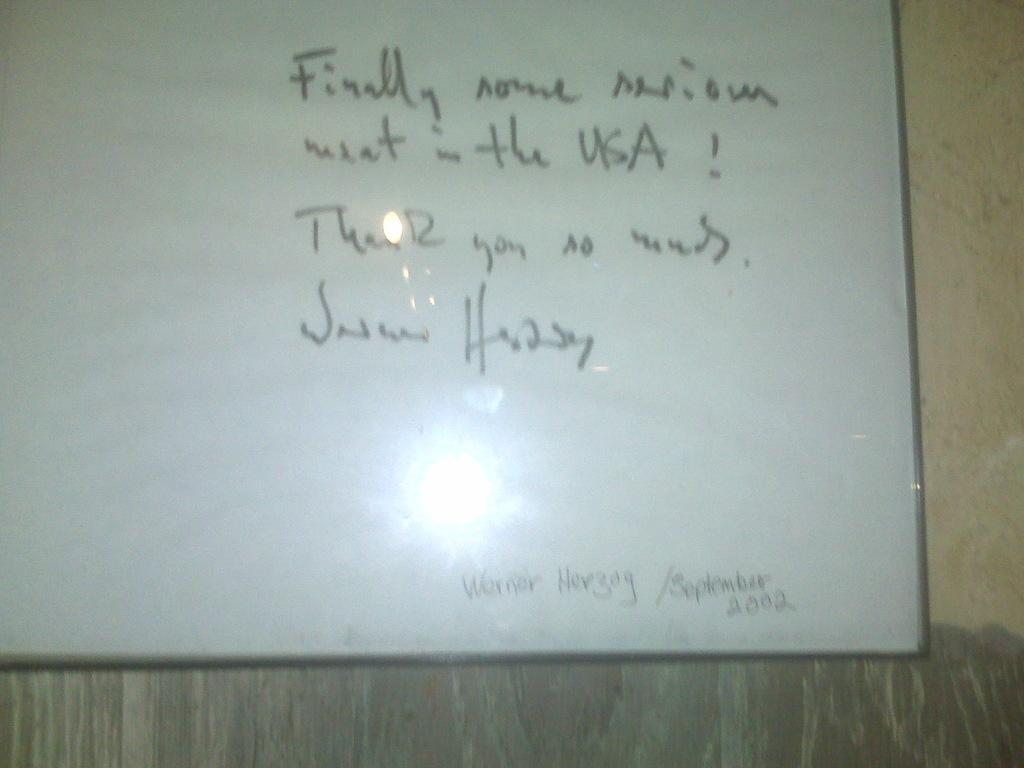<image>
Offer a succinct explanation of the picture presented. White board that says the year 2002 on the bottom. 